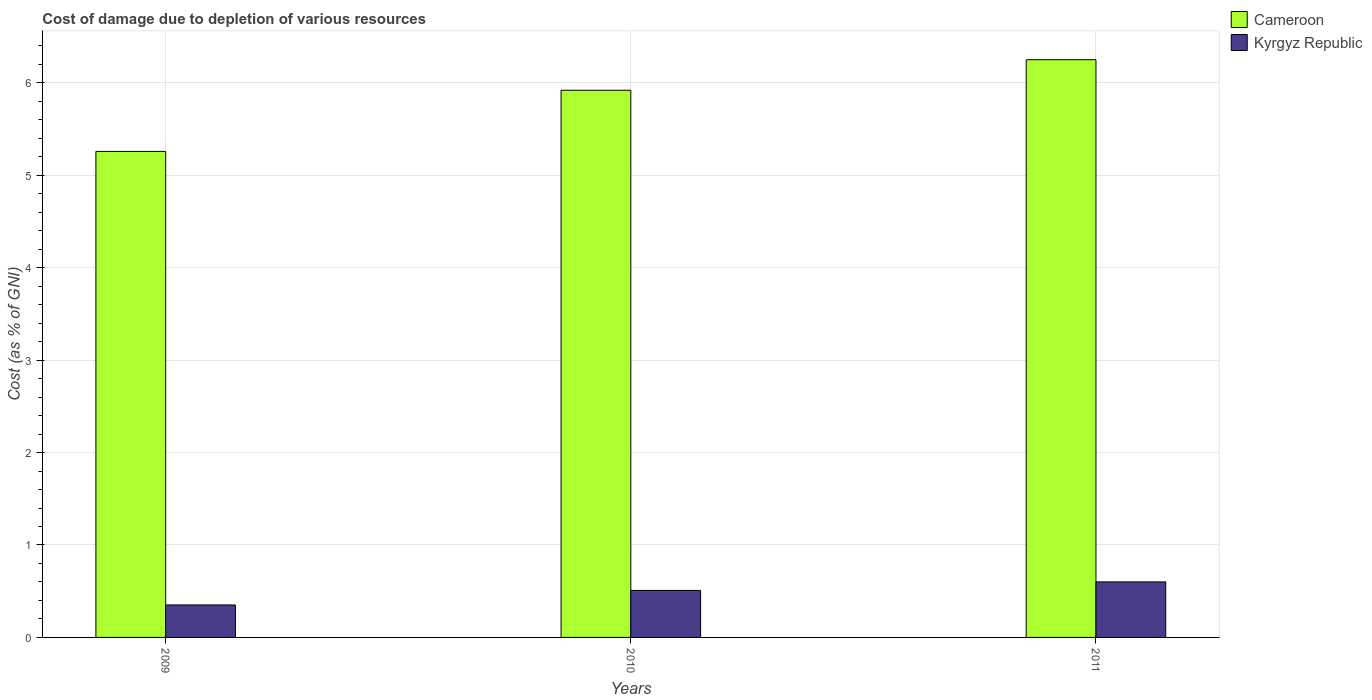How many different coloured bars are there?
Give a very brief answer. 2. Are the number of bars per tick equal to the number of legend labels?
Your response must be concise. Yes. Are the number of bars on each tick of the X-axis equal?
Offer a very short reply. Yes. How many bars are there on the 3rd tick from the right?
Provide a short and direct response. 2. In how many cases, is the number of bars for a given year not equal to the number of legend labels?
Your answer should be compact. 0. What is the cost of damage caused due to the depletion of various resources in Kyrgyz Republic in 2009?
Your answer should be compact. 0.35. Across all years, what is the maximum cost of damage caused due to the depletion of various resources in Cameroon?
Provide a short and direct response. 6.25. Across all years, what is the minimum cost of damage caused due to the depletion of various resources in Kyrgyz Republic?
Make the answer very short. 0.35. In which year was the cost of damage caused due to the depletion of various resources in Kyrgyz Republic minimum?
Ensure brevity in your answer.  2009. What is the total cost of damage caused due to the depletion of various resources in Cameroon in the graph?
Ensure brevity in your answer.  17.43. What is the difference between the cost of damage caused due to the depletion of various resources in Kyrgyz Republic in 2009 and that in 2010?
Ensure brevity in your answer.  -0.16. What is the difference between the cost of damage caused due to the depletion of various resources in Kyrgyz Republic in 2011 and the cost of damage caused due to the depletion of various resources in Cameroon in 2010?
Provide a short and direct response. -5.32. What is the average cost of damage caused due to the depletion of various resources in Kyrgyz Republic per year?
Give a very brief answer. 0.49. In the year 2011, what is the difference between the cost of damage caused due to the depletion of various resources in Cameroon and cost of damage caused due to the depletion of various resources in Kyrgyz Republic?
Offer a terse response. 5.65. What is the ratio of the cost of damage caused due to the depletion of various resources in Cameroon in 2009 to that in 2011?
Provide a short and direct response. 0.84. What is the difference between the highest and the second highest cost of damage caused due to the depletion of various resources in Cameroon?
Offer a very short reply. 0.33. What is the difference between the highest and the lowest cost of damage caused due to the depletion of various resources in Kyrgyz Republic?
Provide a short and direct response. 0.25. Is the sum of the cost of damage caused due to the depletion of various resources in Cameroon in 2009 and 2011 greater than the maximum cost of damage caused due to the depletion of various resources in Kyrgyz Republic across all years?
Provide a succinct answer. Yes. What does the 1st bar from the left in 2011 represents?
Provide a short and direct response. Cameroon. What does the 2nd bar from the right in 2011 represents?
Ensure brevity in your answer.  Cameroon. How many bars are there?
Offer a terse response. 6. Are all the bars in the graph horizontal?
Your response must be concise. No. What is the difference between two consecutive major ticks on the Y-axis?
Your response must be concise. 1. Are the values on the major ticks of Y-axis written in scientific E-notation?
Make the answer very short. No. Does the graph contain grids?
Make the answer very short. Yes. How many legend labels are there?
Make the answer very short. 2. What is the title of the graph?
Offer a terse response. Cost of damage due to depletion of various resources. What is the label or title of the Y-axis?
Offer a very short reply. Cost (as % of GNI). What is the Cost (as % of GNI) of Cameroon in 2009?
Keep it short and to the point. 5.26. What is the Cost (as % of GNI) in Kyrgyz Republic in 2009?
Provide a succinct answer. 0.35. What is the Cost (as % of GNI) in Cameroon in 2010?
Make the answer very short. 5.92. What is the Cost (as % of GNI) in Kyrgyz Republic in 2010?
Your answer should be very brief. 0.51. What is the Cost (as % of GNI) in Cameroon in 2011?
Offer a terse response. 6.25. What is the Cost (as % of GNI) of Kyrgyz Republic in 2011?
Provide a succinct answer. 0.6. Across all years, what is the maximum Cost (as % of GNI) of Cameroon?
Your response must be concise. 6.25. Across all years, what is the maximum Cost (as % of GNI) of Kyrgyz Republic?
Your answer should be compact. 0.6. Across all years, what is the minimum Cost (as % of GNI) in Cameroon?
Your answer should be very brief. 5.26. Across all years, what is the minimum Cost (as % of GNI) of Kyrgyz Republic?
Offer a very short reply. 0.35. What is the total Cost (as % of GNI) of Cameroon in the graph?
Keep it short and to the point. 17.43. What is the total Cost (as % of GNI) in Kyrgyz Republic in the graph?
Your response must be concise. 1.46. What is the difference between the Cost (as % of GNI) of Cameroon in 2009 and that in 2010?
Offer a very short reply. -0.66. What is the difference between the Cost (as % of GNI) of Kyrgyz Republic in 2009 and that in 2010?
Your response must be concise. -0.16. What is the difference between the Cost (as % of GNI) in Cameroon in 2009 and that in 2011?
Keep it short and to the point. -0.99. What is the difference between the Cost (as % of GNI) of Kyrgyz Republic in 2009 and that in 2011?
Your answer should be compact. -0.25. What is the difference between the Cost (as % of GNI) of Cameroon in 2010 and that in 2011?
Your answer should be very brief. -0.33. What is the difference between the Cost (as % of GNI) in Kyrgyz Republic in 2010 and that in 2011?
Ensure brevity in your answer.  -0.09. What is the difference between the Cost (as % of GNI) in Cameroon in 2009 and the Cost (as % of GNI) in Kyrgyz Republic in 2010?
Make the answer very short. 4.75. What is the difference between the Cost (as % of GNI) in Cameroon in 2009 and the Cost (as % of GNI) in Kyrgyz Republic in 2011?
Provide a short and direct response. 4.66. What is the difference between the Cost (as % of GNI) in Cameroon in 2010 and the Cost (as % of GNI) in Kyrgyz Republic in 2011?
Keep it short and to the point. 5.32. What is the average Cost (as % of GNI) in Cameroon per year?
Offer a terse response. 5.81. What is the average Cost (as % of GNI) of Kyrgyz Republic per year?
Your response must be concise. 0.49. In the year 2009, what is the difference between the Cost (as % of GNI) of Cameroon and Cost (as % of GNI) of Kyrgyz Republic?
Your response must be concise. 4.91. In the year 2010, what is the difference between the Cost (as % of GNI) in Cameroon and Cost (as % of GNI) in Kyrgyz Republic?
Your answer should be compact. 5.41. In the year 2011, what is the difference between the Cost (as % of GNI) of Cameroon and Cost (as % of GNI) of Kyrgyz Republic?
Make the answer very short. 5.65. What is the ratio of the Cost (as % of GNI) in Cameroon in 2009 to that in 2010?
Provide a short and direct response. 0.89. What is the ratio of the Cost (as % of GNI) in Kyrgyz Republic in 2009 to that in 2010?
Your answer should be very brief. 0.69. What is the ratio of the Cost (as % of GNI) of Cameroon in 2009 to that in 2011?
Give a very brief answer. 0.84. What is the ratio of the Cost (as % of GNI) of Kyrgyz Republic in 2009 to that in 2011?
Provide a short and direct response. 0.58. What is the ratio of the Cost (as % of GNI) of Cameroon in 2010 to that in 2011?
Offer a terse response. 0.95. What is the ratio of the Cost (as % of GNI) in Kyrgyz Republic in 2010 to that in 2011?
Offer a very short reply. 0.85. What is the difference between the highest and the second highest Cost (as % of GNI) of Cameroon?
Offer a terse response. 0.33. What is the difference between the highest and the second highest Cost (as % of GNI) of Kyrgyz Republic?
Your response must be concise. 0.09. What is the difference between the highest and the lowest Cost (as % of GNI) of Cameroon?
Give a very brief answer. 0.99. What is the difference between the highest and the lowest Cost (as % of GNI) in Kyrgyz Republic?
Offer a terse response. 0.25. 